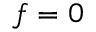<formula> <loc_0><loc_0><loc_500><loc_500>f = 0</formula> 